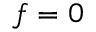<formula> <loc_0><loc_0><loc_500><loc_500>f = 0</formula> 